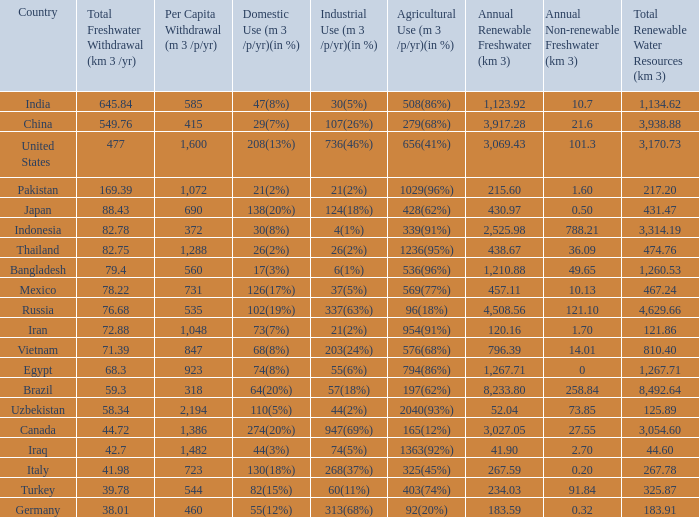What is Agricultural Use (m 3 /p/yr)(in %), when Per Capita Withdrawal (m 3 /p/yr) is greater than 923, and when Domestic Use (m 3 /p/yr)(in %) is 73(7%)? 954(91%). 